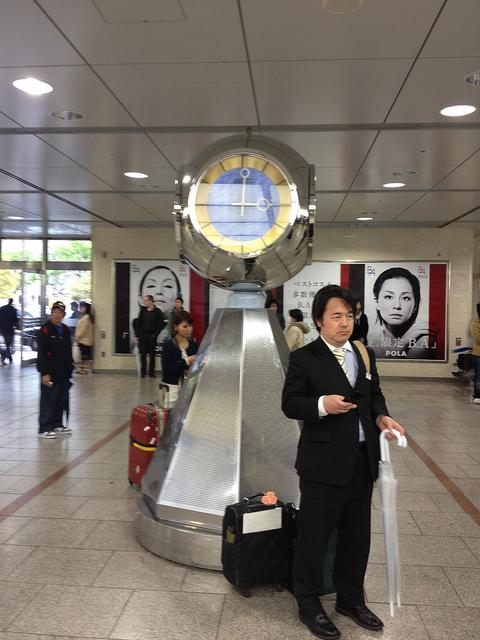What time is it?
Answer briefly. 3:00. How many clocks are there?
Answer briefly. 1. Is this an airport?
Give a very brief answer. Yes. 